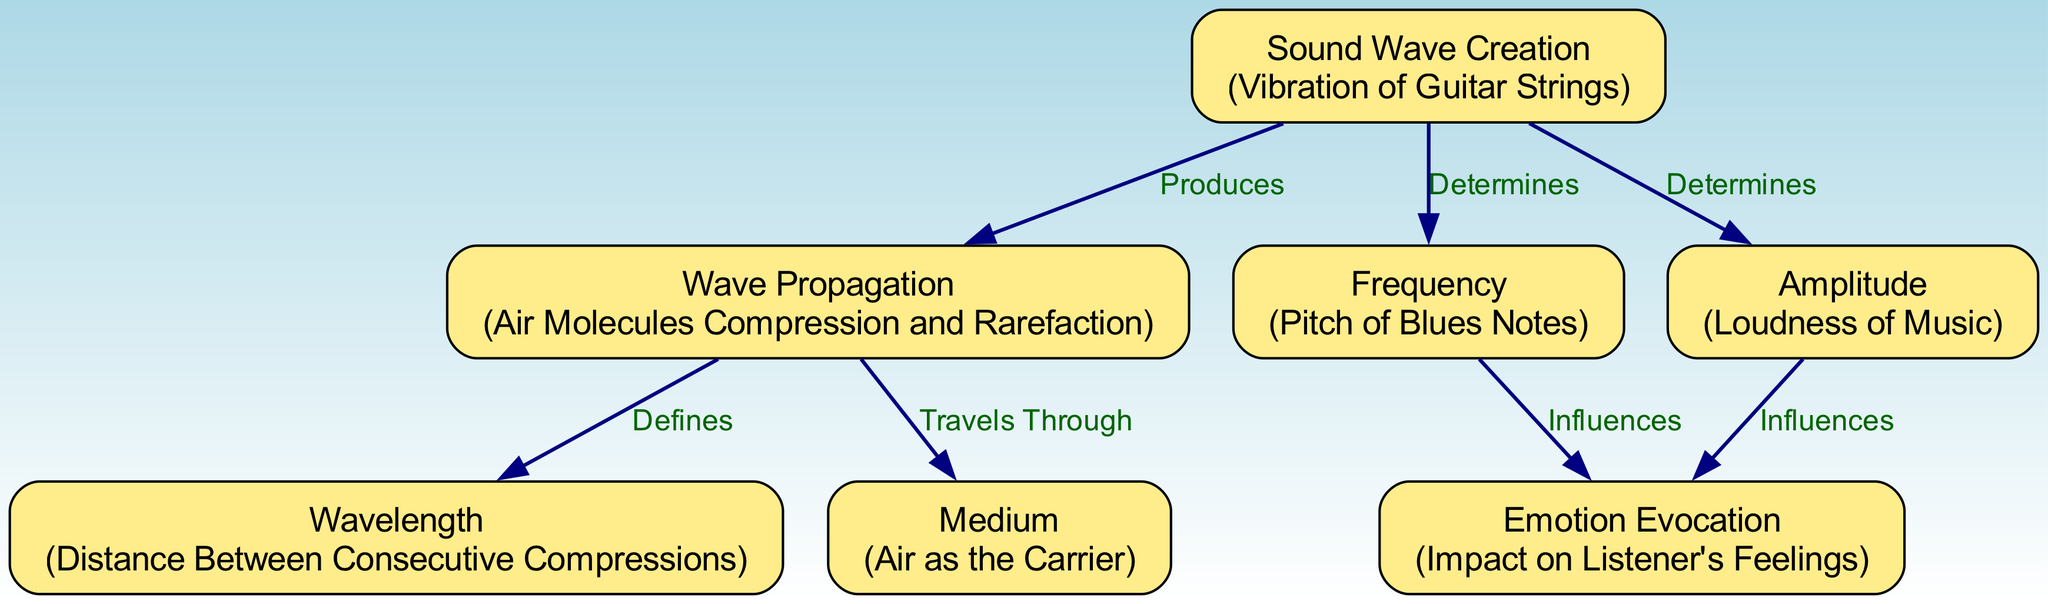What produces sound waves in this diagram? According to the diagram, the "Vibration of Guitar Strings" is shown to produce sound waves, as indicated by the directed edge from "Sound Wave Creation" to "Wave Propagation."
Answer: Vibration of Guitar Strings How many elements are represented in the diagram? The diagram contains a total of 7 elements listed, including sound wave creation, wave propagation, frequency, amplitude, wavelength, medium, and emotion evocation.
Answer: 7 What does the "Amplitude" influence? The diagram illustrates that "Amplitude" influences "Emotion Evocation," as shown by the directed edge connecting these two elements.
Answer: Emotion Evocation What is the medium through which blues music travels? The diagram explicitly states that "Air" is the medium, labeled as "Air as the Carrier." It connects the element "Wave Propagation" to "Medium."
Answer: Air How does "Frequency" affect the listener? The diagram states that "Frequency" influences the "Emotion Evocation" of the listener's feelings, based on the directed edge from "Frequency" to "Emotion Evocation."
Answer: Emotion Evocation What defines the "Wavelength" in sound waves? According to the diagram, "Wavelength" is defined by the "Distance Between Consecutive Compressions," which is directly linked from the element "Wave Propagation."
Answer: Distance Between Consecutive Compressions What determines both the "Frequency" and the "Amplitude"? The diagram shows that both "Frequency" and "Amplitude" are determined by "Sound Wave Creation," as indicated by the respective directed edges from "Sound Wave Creation" to these two elements.
Answer: Sound Wave Creation What travels through the air as indicated in the diagram? The diagram indicates that sound waves, resulting from the "Vibration of Guitar Strings," travel through the "Air" medium, which is connected to "Wave Propagation."
Answer: Sound waves 